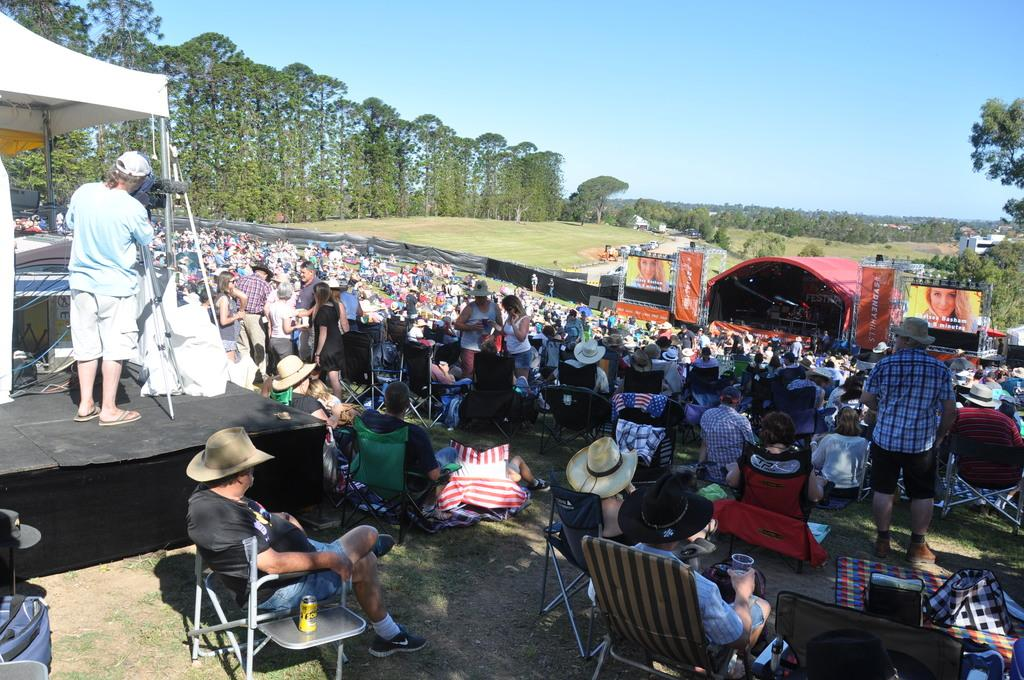What are the people in the image doing? There are people sitting on chairs and standing in the image. What can be seen in the background of the image? Trees and the sky are visible in the image. What type of hose can be seen in the image? There is no hose present in the image. What year is depicted in the image? The image does not depict a specific year; it is a general scene of people and their surroundings. 